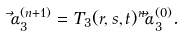<formula> <loc_0><loc_0><loc_500><loc_500>\vec { \alpha } ^ { ( n + 1 ) } _ { 3 } = T _ { 3 } ( r , s , t ) ^ { n } \vec { \alpha } ^ { ( 0 ) } _ { 3 } .</formula> 